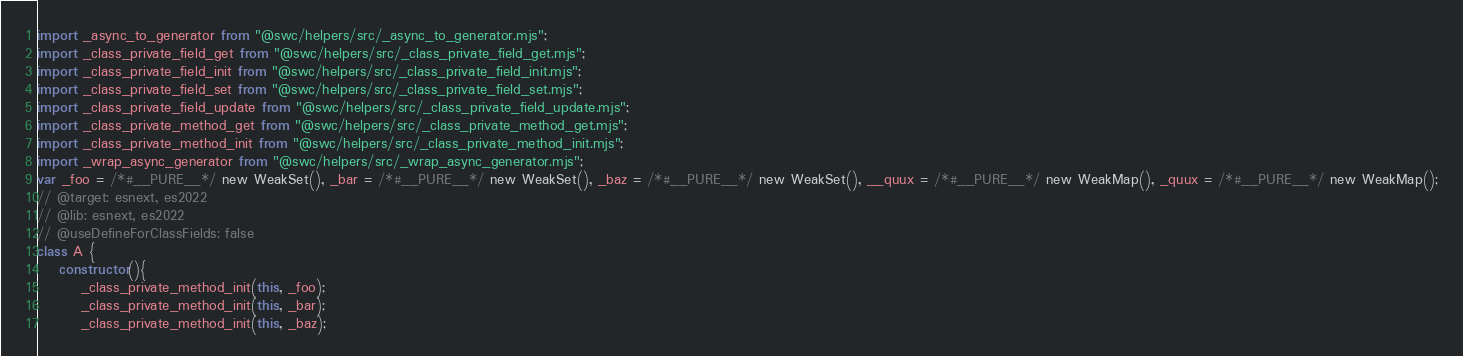<code> <loc_0><loc_0><loc_500><loc_500><_JavaScript_>import _async_to_generator from "@swc/helpers/src/_async_to_generator.mjs";
import _class_private_field_get from "@swc/helpers/src/_class_private_field_get.mjs";
import _class_private_field_init from "@swc/helpers/src/_class_private_field_init.mjs";
import _class_private_field_set from "@swc/helpers/src/_class_private_field_set.mjs";
import _class_private_field_update from "@swc/helpers/src/_class_private_field_update.mjs";
import _class_private_method_get from "@swc/helpers/src/_class_private_method_get.mjs";
import _class_private_method_init from "@swc/helpers/src/_class_private_method_init.mjs";
import _wrap_async_generator from "@swc/helpers/src/_wrap_async_generator.mjs";
var _foo = /*#__PURE__*/ new WeakSet(), _bar = /*#__PURE__*/ new WeakSet(), _baz = /*#__PURE__*/ new WeakSet(), __quux = /*#__PURE__*/ new WeakMap(), _quux = /*#__PURE__*/ new WeakMap();
// @target: esnext, es2022
// @lib: esnext, es2022
// @useDefineForClassFields: false
class A {
    constructor(){
        _class_private_method_init(this, _foo);
        _class_private_method_init(this, _bar);
        _class_private_method_init(this, _baz);</code> 